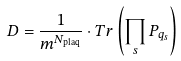<formula> <loc_0><loc_0><loc_500><loc_500>D = \frac { 1 } { m ^ { N _ { \text {plaq} } } } \cdot T r \left ( \prod _ { s } P _ { q _ { s } } \right )</formula> 